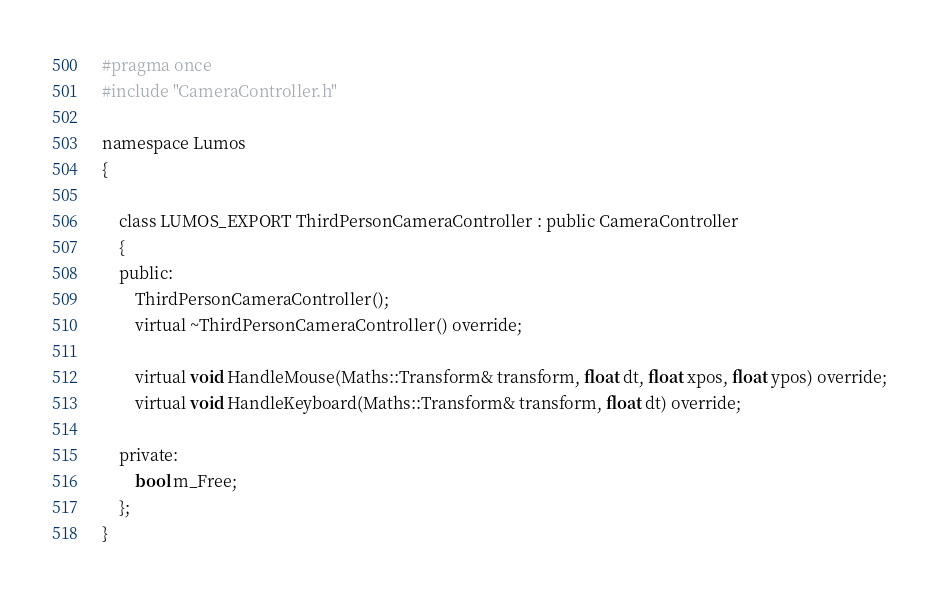Convert code to text. <code><loc_0><loc_0><loc_500><loc_500><_C_>#pragma once
#include "CameraController.h"

namespace Lumos
{

    class LUMOS_EXPORT ThirdPersonCameraController : public CameraController
    {
    public:
        ThirdPersonCameraController();
        virtual ~ThirdPersonCameraController() override;

        virtual void HandleMouse(Maths::Transform& transform, float dt, float xpos, float ypos) override;
        virtual void HandleKeyboard(Maths::Transform& transform, float dt) override;

    private:
        bool m_Free;
    };
}
</code> 